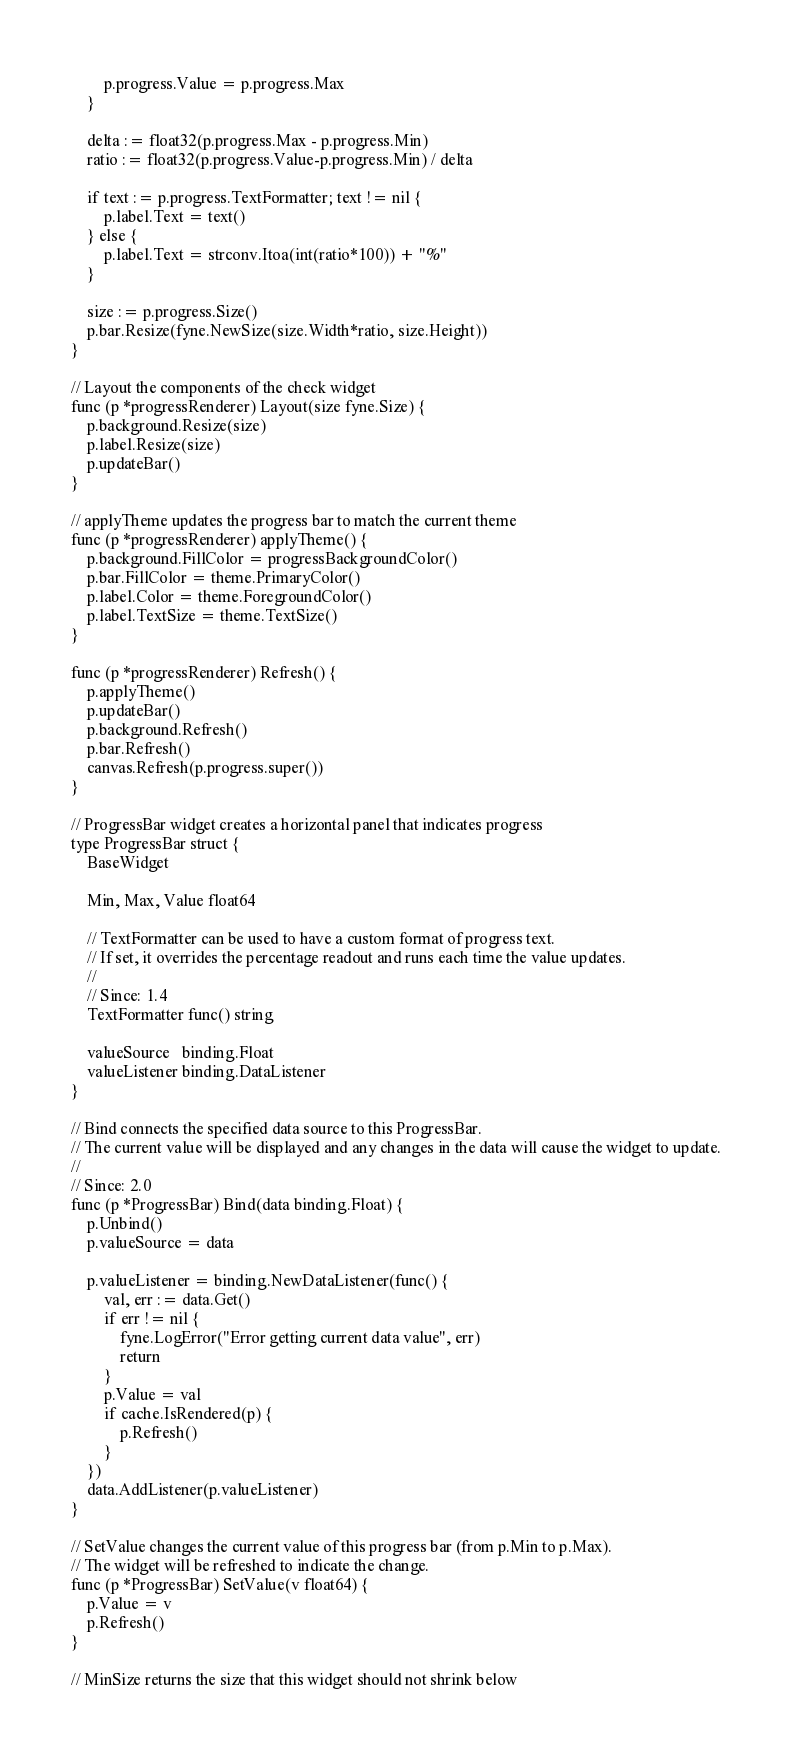Convert code to text. <code><loc_0><loc_0><loc_500><loc_500><_Go_>		p.progress.Value = p.progress.Max
	}

	delta := float32(p.progress.Max - p.progress.Min)
	ratio := float32(p.progress.Value-p.progress.Min) / delta

	if text := p.progress.TextFormatter; text != nil {
		p.label.Text = text()
	} else {
		p.label.Text = strconv.Itoa(int(ratio*100)) + "%"
	}

	size := p.progress.Size()
	p.bar.Resize(fyne.NewSize(size.Width*ratio, size.Height))
}

// Layout the components of the check widget
func (p *progressRenderer) Layout(size fyne.Size) {
	p.background.Resize(size)
	p.label.Resize(size)
	p.updateBar()
}

// applyTheme updates the progress bar to match the current theme
func (p *progressRenderer) applyTheme() {
	p.background.FillColor = progressBackgroundColor()
	p.bar.FillColor = theme.PrimaryColor()
	p.label.Color = theme.ForegroundColor()
	p.label.TextSize = theme.TextSize()
}

func (p *progressRenderer) Refresh() {
	p.applyTheme()
	p.updateBar()
	p.background.Refresh()
	p.bar.Refresh()
	canvas.Refresh(p.progress.super())
}

// ProgressBar widget creates a horizontal panel that indicates progress
type ProgressBar struct {
	BaseWidget

	Min, Max, Value float64

	// TextFormatter can be used to have a custom format of progress text.
	// If set, it overrides the percentage readout and runs each time the value updates.
	//
	// Since: 1.4
	TextFormatter func() string

	valueSource   binding.Float
	valueListener binding.DataListener
}

// Bind connects the specified data source to this ProgressBar.
// The current value will be displayed and any changes in the data will cause the widget to update.
//
// Since: 2.0
func (p *ProgressBar) Bind(data binding.Float) {
	p.Unbind()
	p.valueSource = data

	p.valueListener = binding.NewDataListener(func() {
		val, err := data.Get()
		if err != nil {
			fyne.LogError("Error getting current data value", err)
			return
		}
		p.Value = val
		if cache.IsRendered(p) {
			p.Refresh()
		}
	})
	data.AddListener(p.valueListener)
}

// SetValue changes the current value of this progress bar (from p.Min to p.Max).
// The widget will be refreshed to indicate the change.
func (p *ProgressBar) SetValue(v float64) {
	p.Value = v
	p.Refresh()
}

// MinSize returns the size that this widget should not shrink below</code> 